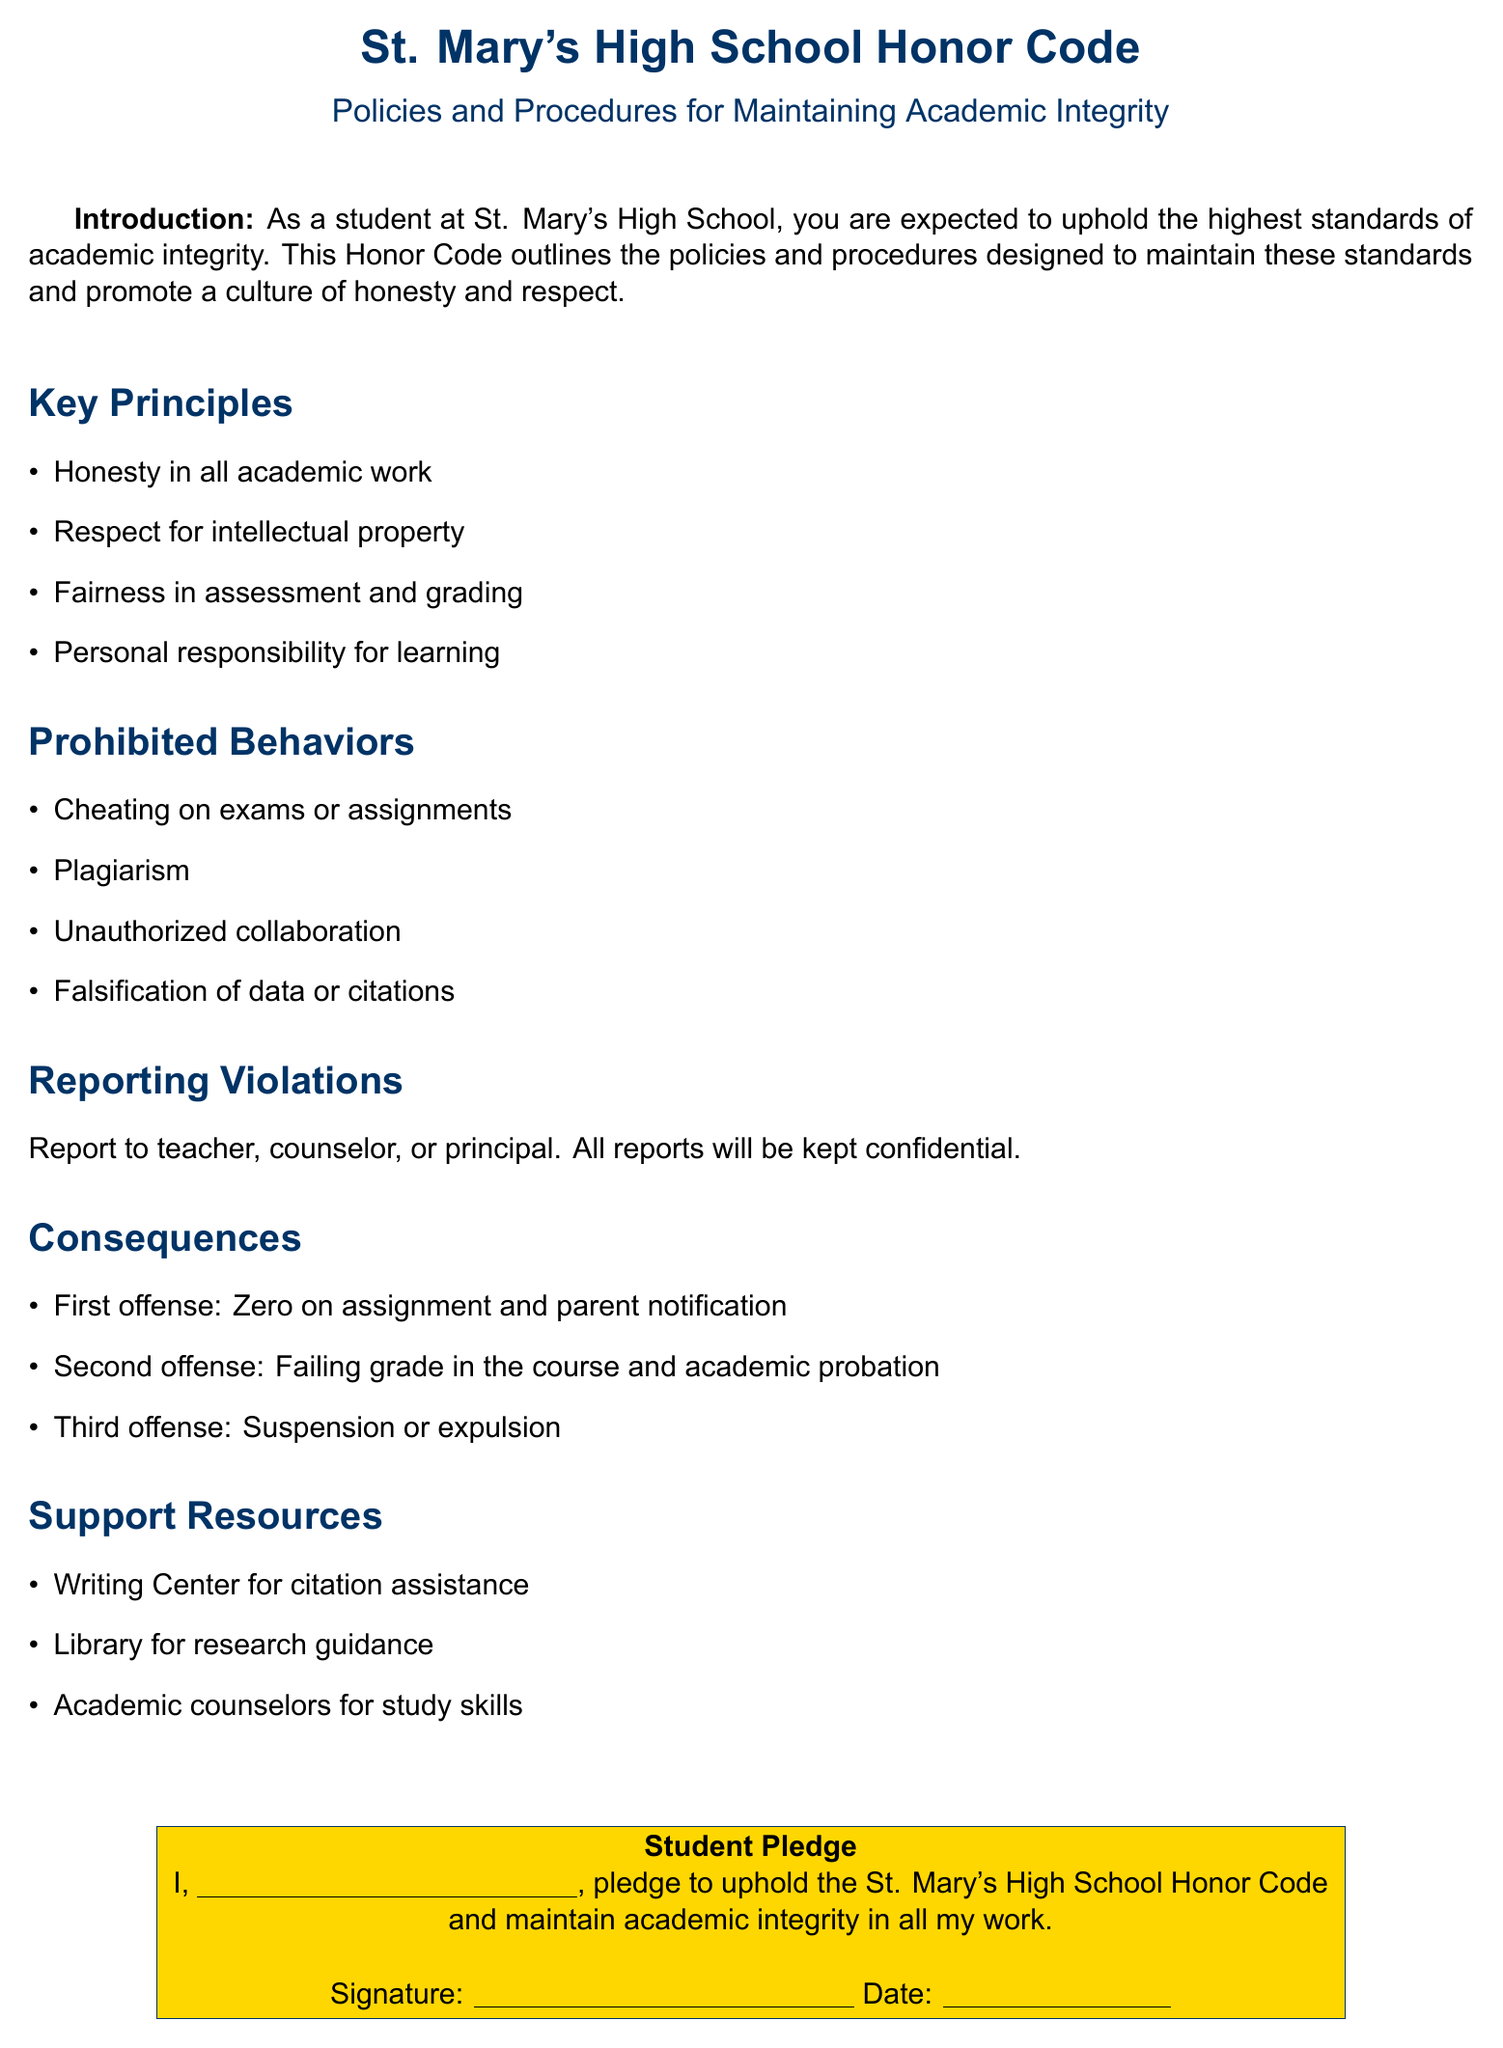What is the name of the school? The document specifies that the name of the school is St. Mary's High School.
Answer: St. Mary's High School What are the key principles? The document lists four key principles related to academic integrity.
Answer: Honesty, Respect, Fairness, Responsibility What is considered plagiarism? The document defines prohibited behaviors, and plagiarism falls under those behaviors.
Answer: Plagiarism Who should violations be reported to? The document specifies who to report violations to within the school.
Answer: Teacher, counselor, or principal What is the consequence of a first offense? The document outlines the consequences for violations based on the number of offenses, starting with the first.
Answer: Zero on assignment and parent notification What support resources are available? The document lists resources that offer support related to academic integrity.
Answer: Writing Center, Library, Academic counselors What happens on a second offense? The document details the consequences for a second offense of the Honor Code.
Answer: Failing grade in the course and academic probation What must students pledge to do? The document includes a student pledge that emphasizes an essential commitment.
Answer: Uphold the St. Mary's High School Honor Code What color is used for the primary headings? The document specifies a color for its primary headings throughout.
Answer: Primary color: RGB(0,51,102) 